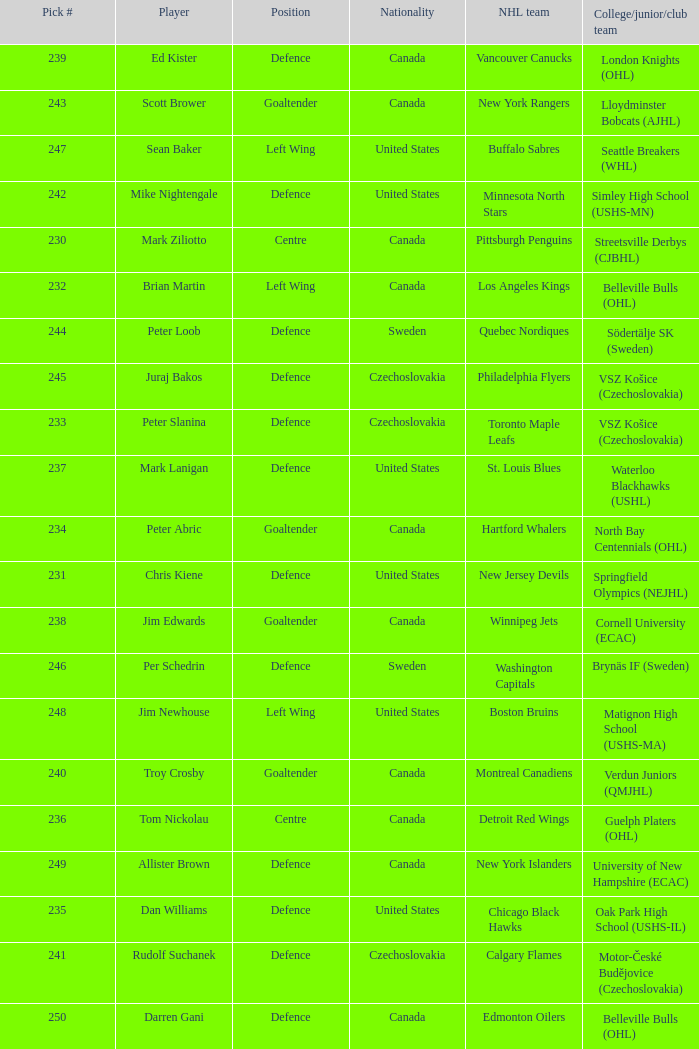List the players for team brynäs if (sweden). Per Schedrin. 